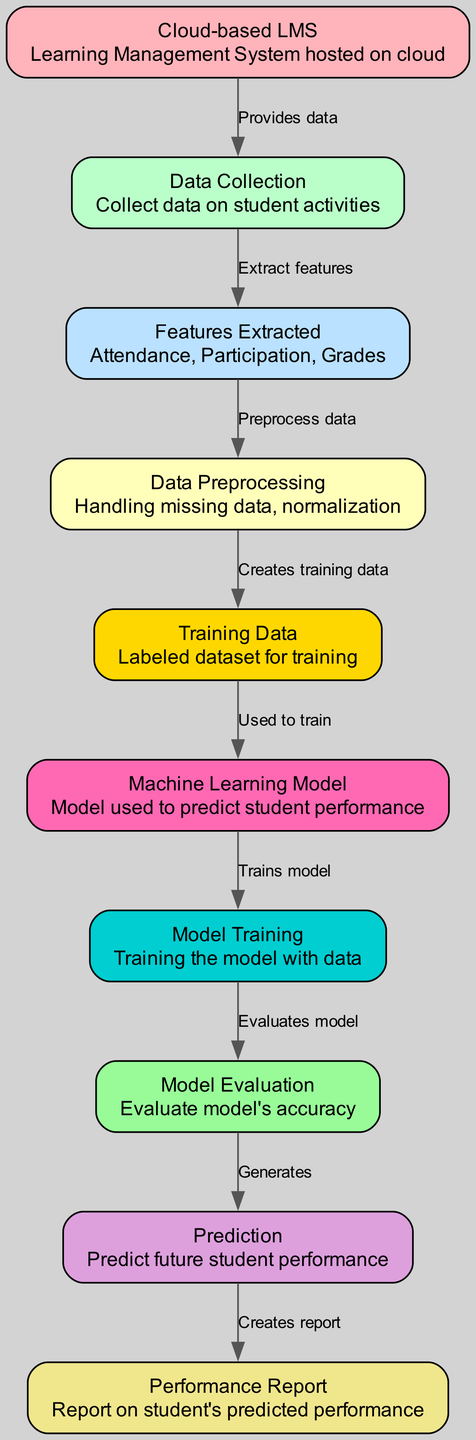What is the primary source of data in the diagram? The primary source of data is the "Cloud-based LMS," which provides data about student activities.
Answer: Cloud-based LMS How many nodes are there in the diagram? The diagram has a total of 10 nodes, each representing different elements in the machine learning process for predicting student performance.
Answer: 10 What feature is extracted from student activities? The features extracted from student activities include "Attendance, Participation, Grades," which are essential for predicting student performance.
Answer: Attendance, Participation, Grades What process follows data preprocessing? After data preprocessing, the next step is creating the "Training Data," where the processed data is organized into a labeled dataset for the machine learning model.
Answer: Creates training data Which node evaluates the model's accuracy? The "Model Evaluation" node is responsible for assessing the accuracy of the machine learning model after it has been trained.
Answer: Model Evaluation What does the "Prediction" node generate? The "Prediction" node generates future student performance predictions based on the inputs processed through the machine learning model.
Answer: Predict future student performance What type of data does the "Data Collection" node gather? The "Data Collection" node gathers data on student activities as the initial step in the pipeline leading to performance prediction.
Answer: Student activities How many edges are there connecting the nodes? There are 9 edges connecting the nodes, representing the relationships and flow of data between different processes in the diagram.
Answer: 9 What node creates a performance report? The "Performance Report" node creates a report that summarizes each student's predicted performance based on the model's predictions.
Answer: Performance Report 